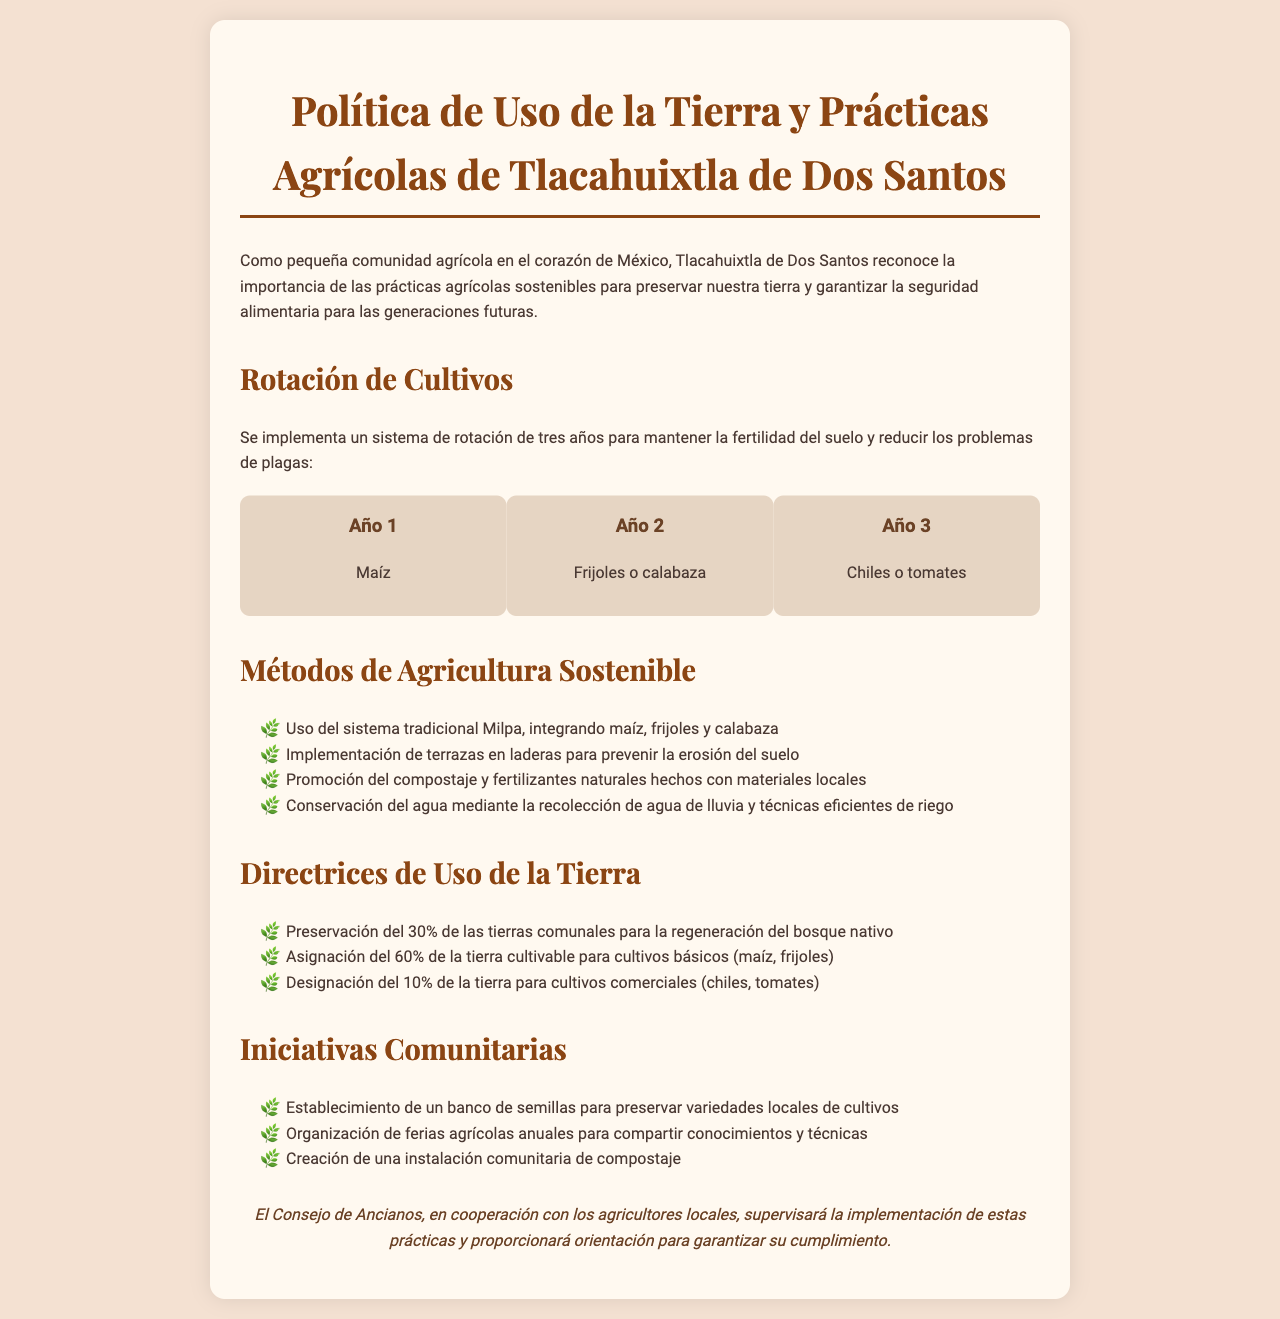¿Cuáles son los cultivos del primer año en el sistema de rotación? El primer año en el sistema de rotación de cultivos se detalla como maíz.
Answer: Maíz ¿Qué porcentaje de las tierras comunales se debe preservar para la regeneración del bosque? El documento indica que se debe preservar el 30% de las tierras comunales.
Answer: 30% ¿Cuál es el método tradicional mencionado para integrar cultivos? Se hace referencia al sistema tradicional Milpa como método.
Answer: Milpa ¿Cuáles son los cultivos asignados para el 60% de la tierra cultivable? El uso de la tierra menciona que el 60% se asigna para cultivos básicos como maíz y frijoles.
Answer: maíz, frijoles ¿Cuántos años se establece para el sistema de rotación de cultivos? La política menciona un sistema de rotación de cultivos de tres años.
Answer: tres años ¿Qué tipo de instalaciones comunitarias se proponen en las iniciativas? Se sugiere la creación de una instalación comunitaria de compostaje en las iniciativas comunitarias.
Answer: instalación comunitaria de compostaje ¿Cuáles son los cultivos designados para el 10% de la tierra? El documento especifica que el 10% de la tierra se designa para cultivos comerciales como chiles y tomates.
Answer: chiles, tomates 